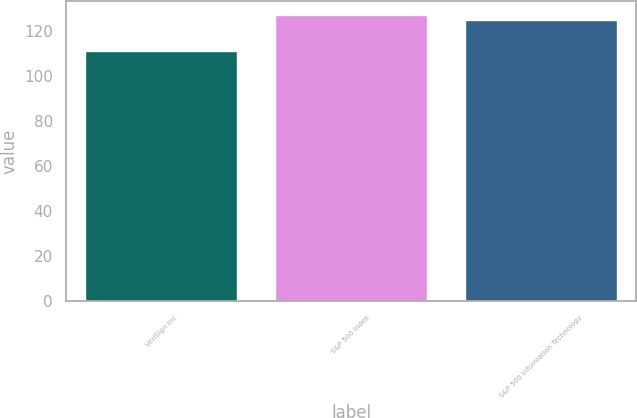<chart> <loc_0><loc_0><loc_500><loc_500><bar_chart><fcel>VeriSign Inc<fcel>S&P 500 Index<fcel>S&P 500 Information Technology<nl><fcel>111<fcel>127<fcel>125<nl></chart> 